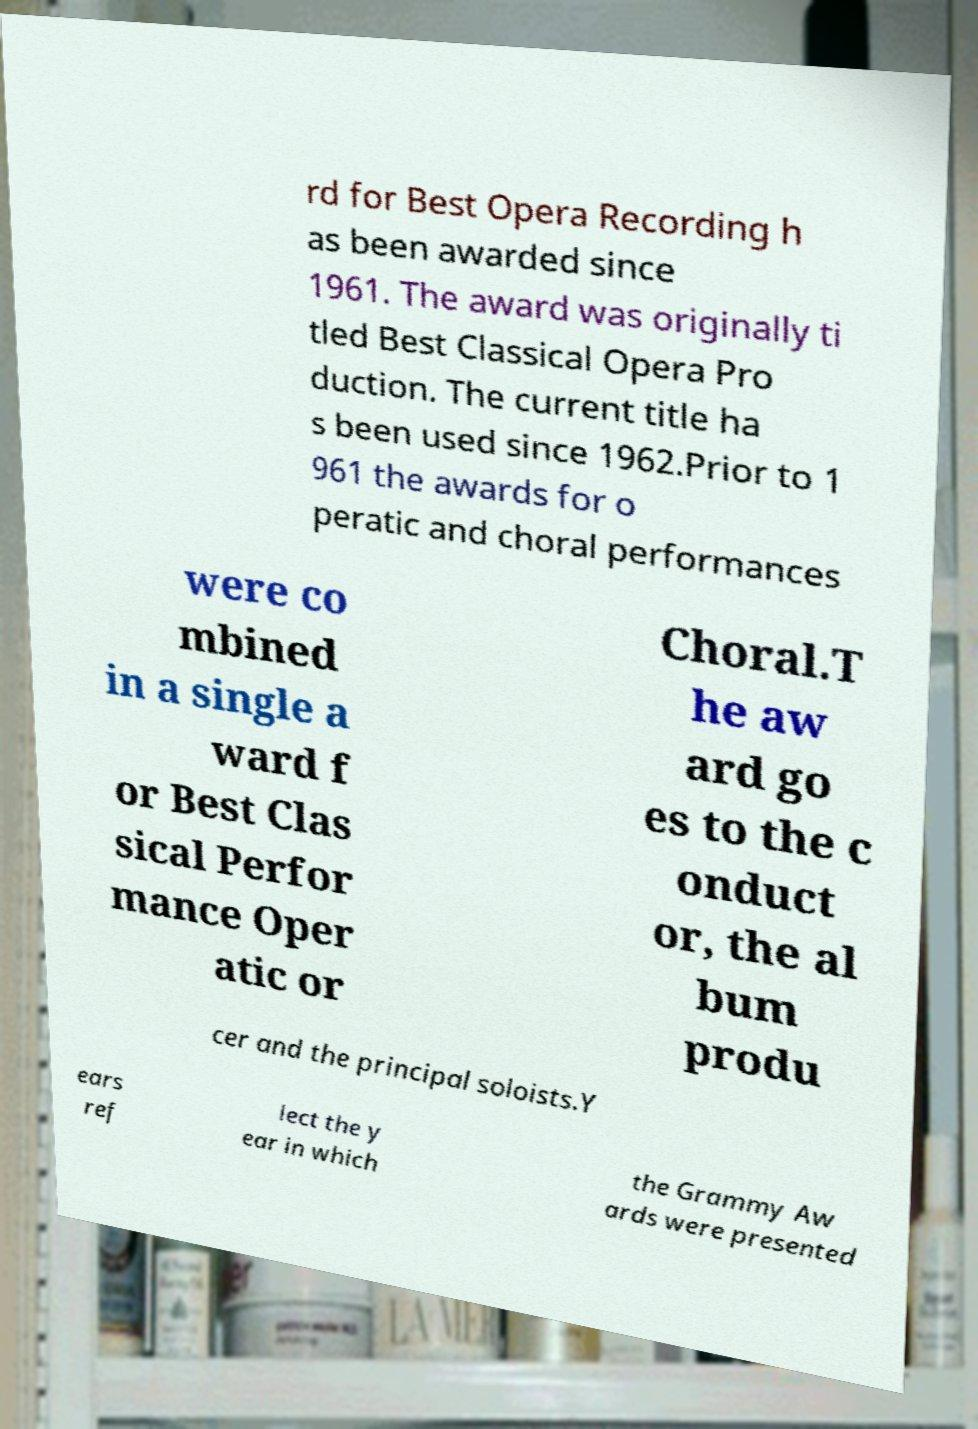What messages or text are displayed in this image? I need them in a readable, typed format. rd for Best Opera Recording h as been awarded since 1961. The award was originally ti tled Best Classical Opera Pro duction. The current title ha s been used since 1962.Prior to 1 961 the awards for o peratic and choral performances were co mbined in a single a ward f or Best Clas sical Perfor mance Oper atic or Choral.T he aw ard go es to the c onduct or, the al bum produ cer and the principal soloists.Y ears ref lect the y ear in which the Grammy Aw ards were presented 